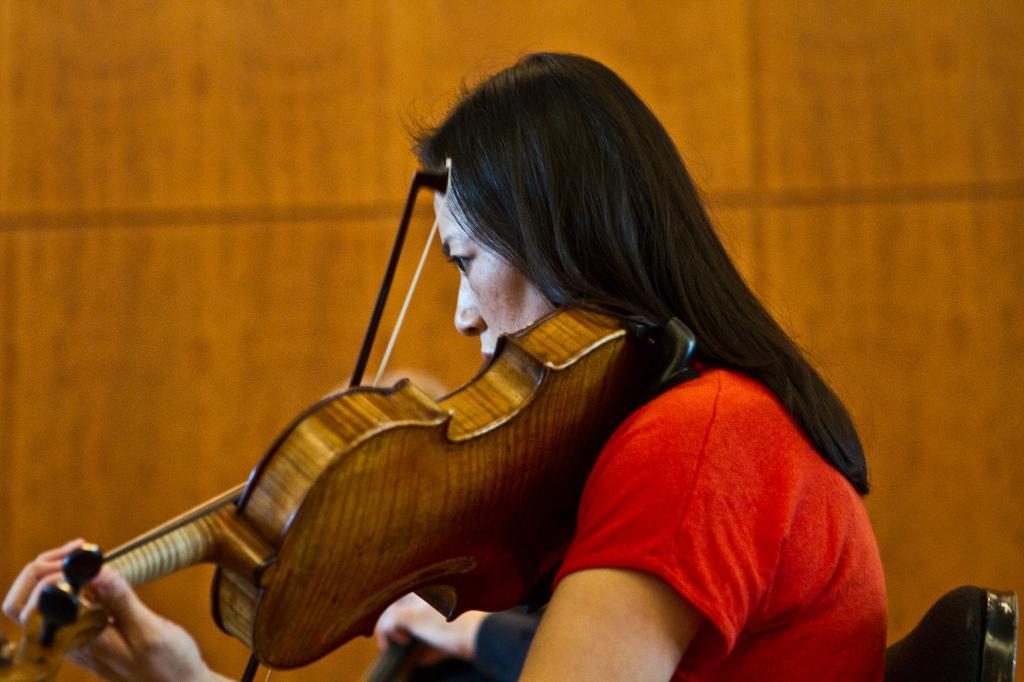Who is the main subject in the image? There is a woman in the image. What is the woman doing in the image? The woman is sitting on a chair and playing a guitar. What is the woman wearing in the image? The woman is wearing a red dress. What is the woman thinking about while playing the guitar in the image? There is no way to determine what the woman is thinking about from the image alone. 